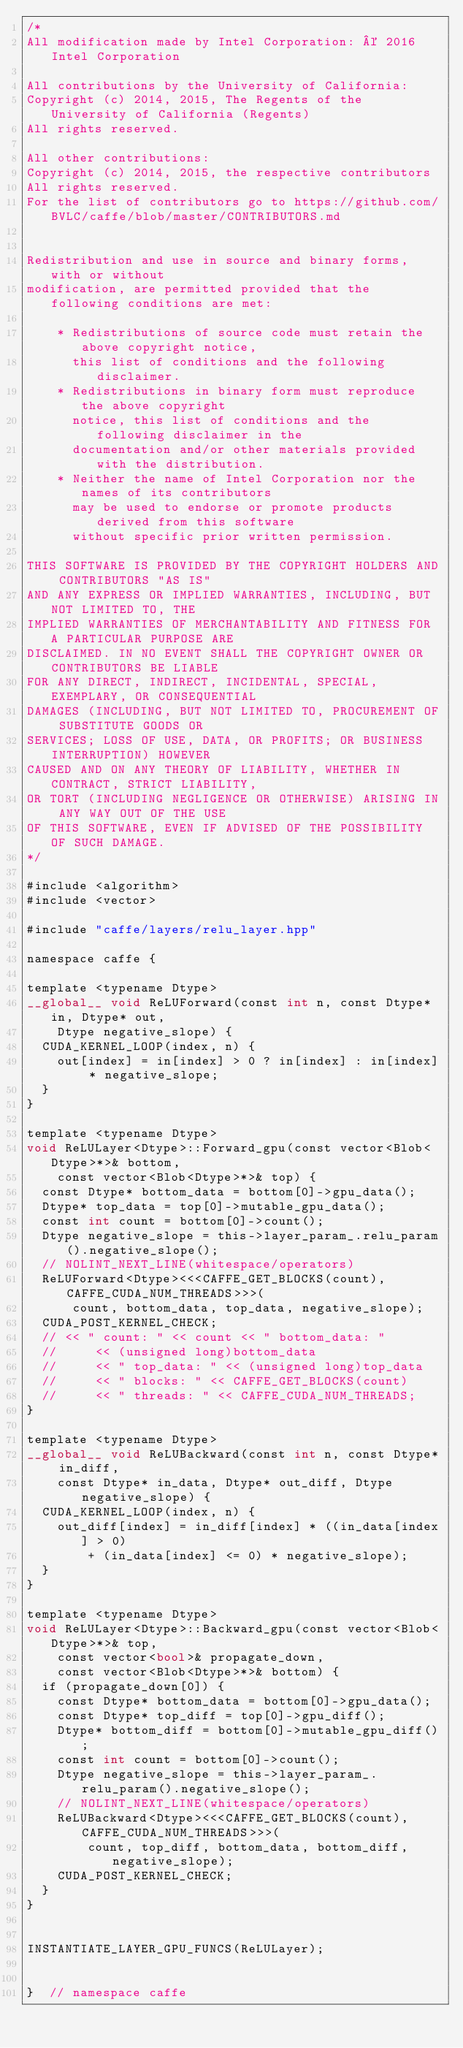Convert code to text. <code><loc_0><loc_0><loc_500><loc_500><_Cuda_>/*
All modification made by Intel Corporation: © 2016 Intel Corporation

All contributions by the University of California:
Copyright (c) 2014, 2015, The Regents of the University of California (Regents)
All rights reserved.

All other contributions:
Copyright (c) 2014, 2015, the respective contributors
All rights reserved.
For the list of contributors go to https://github.com/BVLC/caffe/blob/master/CONTRIBUTORS.md


Redistribution and use in source and binary forms, with or without
modification, are permitted provided that the following conditions are met:

    * Redistributions of source code must retain the above copyright notice,
      this list of conditions and the following disclaimer.
    * Redistributions in binary form must reproduce the above copyright
      notice, this list of conditions and the following disclaimer in the
      documentation and/or other materials provided with the distribution.
    * Neither the name of Intel Corporation nor the names of its contributors
      may be used to endorse or promote products derived from this software
      without specific prior written permission.

THIS SOFTWARE IS PROVIDED BY THE COPYRIGHT HOLDERS AND CONTRIBUTORS "AS IS"
AND ANY EXPRESS OR IMPLIED WARRANTIES, INCLUDING, BUT NOT LIMITED TO, THE
IMPLIED WARRANTIES OF MERCHANTABILITY AND FITNESS FOR A PARTICULAR PURPOSE ARE
DISCLAIMED. IN NO EVENT SHALL THE COPYRIGHT OWNER OR CONTRIBUTORS BE LIABLE
FOR ANY DIRECT, INDIRECT, INCIDENTAL, SPECIAL, EXEMPLARY, OR CONSEQUENTIAL
DAMAGES (INCLUDING, BUT NOT LIMITED TO, PROCUREMENT OF SUBSTITUTE GOODS OR
SERVICES; LOSS OF USE, DATA, OR PROFITS; OR BUSINESS INTERRUPTION) HOWEVER
CAUSED AND ON ANY THEORY OF LIABILITY, WHETHER IN CONTRACT, STRICT LIABILITY,
OR TORT (INCLUDING NEGLIGENCE OR OTHERWISE) ARISING IN ANY WAY OUT OF THE USE
OF THIS SOFTWARE, EVEN IF ADVISED OF THE POSSIBILITY OF SUCH DAMAGE.
*/

#include <algorithm>
#include <vector>

#include "caffe/layers/relu_layer.hpp"

namespace caffe {

template <typename Dtype>
__global__ void ReLUForward(const int n, const Dtype* in, Dtype* out,
    Dtype negative_slope) {
  CUDA_KERNEL_LOOP(index, n) {
    out[index] = in[index] > 0 ? in[index] : in[index] * negative_slope;
  }
}

template <typename Dtype>
void ReLULayer<Dtype>::Forward_gpu(const vector<Blob<Dtype>*>& bottom,
    const vector<Blob<Dtype>*>& top) {
  const Dtype* bottom_data = bottom[0]->gpu_data();
  Dtype* top_data = top[0]->mutable_gpu_data();
  const int count = bottom[0]->count();
  Dtype negative_slope = this->layer_param_.relu_param().negative_slope();
  // NOLINT_NEXT_LINE(whitespace/operators)
  ReLUForward<Dtype><<<CAFFE_GET_BLOCKS(count), CAFFE_CUDA_NUM_THREADS>>>(
      count, bottom_data, top_data, negative_slope);
  CUDA_POST_KERNEL_CHECK;
  // << " count: " << count << " bottom_data: "
  //     << (unsigned long)bottom_data
  //     << " top_data: " << (unsigned long)top_data
  //     << " blocks: " << CAFFE_GET_BLOCKS(count)
  //     << " threads: " << CAFFE_CUDA_NUM_THREADS;
}

template <typename Dtype>
__global__ void ReLUBackward(const int n, const Dtype* in_diff,
    const Dtype* in_data, Dtype* out_diff, Dtype negative_slope) {
  CUDA_KERNEL_LOOP(index, n) {
    out_diff[index] = in_diff[index] * ((in_data[index] > 0)
        + (in_data[index] <= 0) * negative_slope);
  }
}

template <typename Dtype>
void ReLULayer<Dtype>::Backward_gpu(const vector<Blob<Dtype>*>& top,
    const vector<bool>& propagate_down,
    const vector<Blob<Dtype>*>& bottom) {
  if (propagate_down[0]) {
    const Dtype* bottom_data = bottom[0]->gpu_data();
    const Dtype* top_diff = top[0]->gpu_diff();
    Dtype* bottom_diff = bottom[0]->mutable_gpu_diff();
    const int count = bottom[0]->count();
    Dtype negative_slope = this->layer_param_.relu_param().negative_slope();
    // NOLINT_NEXT_LINE(whitespace/operators)
    ReLUBackward<Dtype><<<CAFFE_GET_BLOCKS(count), CAFFE_CUDA_NUM_THREADS>>>(
        count, top_diff, bottom_data, bottom_diff, negative_slope);
    CUDA_POST_KERNEL_CHECK;
  }
}


INSTANTIATE_LAYER_GPU_FUNCS(ReLULayer);


}  // namespace caffe
</code> 